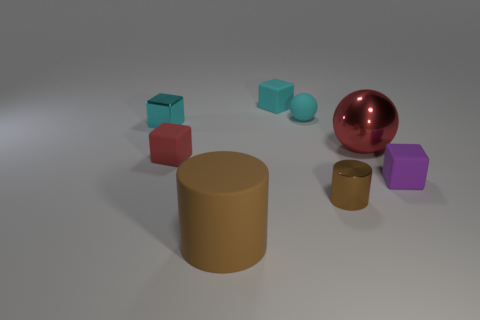Subtract all green balls. How many cyan cubes are left? 2 Subtract all tiny matte cubes. How many cubes are left? 1 Subtract all green cubes. Subtract all yellow spheres. How many cubes are left? 4 Add 1 blue spheres. How many objects exist? 9 Subtract all tiny green shiny cubes. Subtract all cyan metal blocks. How many objects are left? 7 Add 1 tiny cyan metal blocks. How many tiny cyan metal blocks are left? 2 Add 5 big green rubber things. How many big green rubber things exist? 5 Subtract 0 brown spheres. How many objects are left? 8 Subtract all cylinders. How many objects are left? 6 